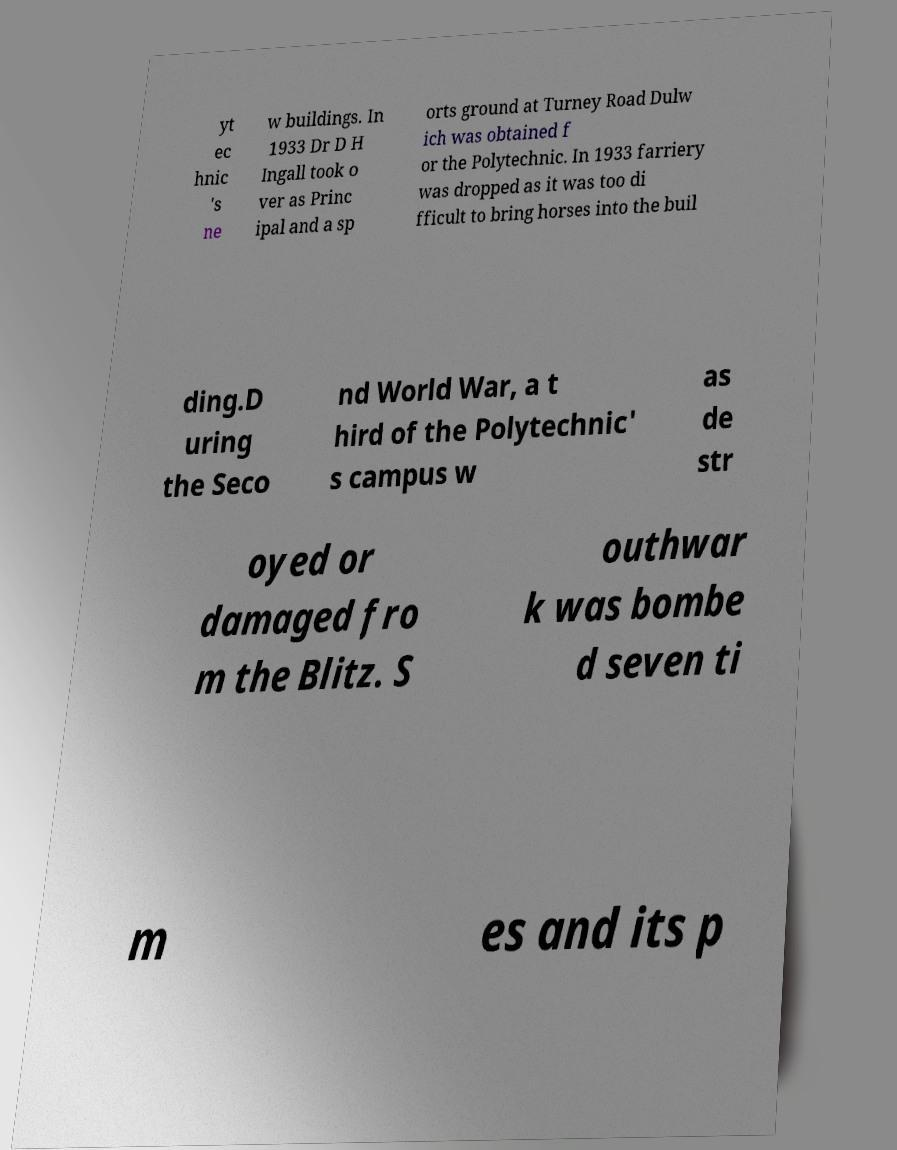What messages or text are displayed in this image? I need them in a readable, typed format. yt ec hnic 's ne w buildings. In 1933 Dr D H Ingall took o ver as Princ ipal and a sp orts ground at Turney Road Dulw ich was obtained f or the Polytechnic. In 1933 farriery was dropped as it was too di fficult to bring horses into the buil ding.D uring the Seco nd World War, a t hird of the Polytechnic' s campus w as de str oyed or damaged fro m the Blitz. S outhwar k was bombe d seven ti m es and its p 